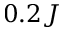Convert formula to latex. <formula><loc_0><loc_0><loc_500><loc_500>0 . 2 J</formula> 